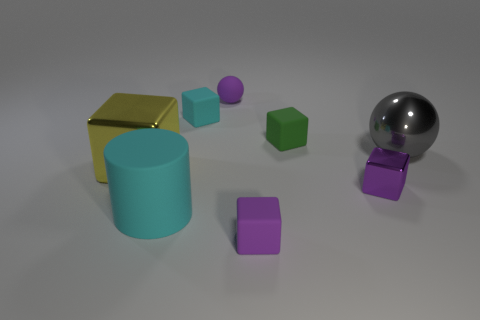Subtract all small cyan cubes. How many cubes are left? 4 Subtract all green cubes. How many cubes are left? 4 Subtract all gray cubes. Subtract all blue cylinders. How many cubes are left? 5 Add 1 small cyan blocks. How many objects exist? 9 Subtract all blocks. How many objects are left? 3 Add 4 purple blocks. How many purple blocks are left? 6 Add 3 gray objects. How many gray objects exist? 4 Subtract 0 green spheres. How many objects are left? 8 Subtract all large gray things. Subtract all gray metallic objects. How many objects are left? 6 